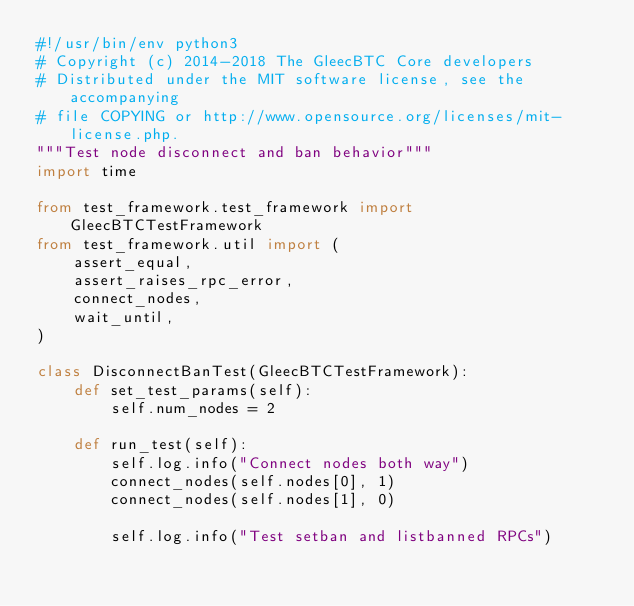Convert code to text. <code><loc_0><loc_0><loc_500><loc_500><_Python_>#!/usr/bin/env python3
# Copyright (c) 2014-2018 The GleecBTC Core developers
# Distributed under the MIT software license, see the accompanying
# file COPYING or http://www.opensource.org/licenses/mit-license.php.
"""Test node disconnect and ban behavior"""
import time

from test_framework.test_framework import GleecBTCTestFramework
from test_framework.util import (
    assert_equal,
    assert_raises_rpc_error,
    connect_nodes,
    wait_until,
)

class DisconnectBanTest(GleecBTCTestFramework):
    def set_test_params(self):
        self.num_nodes = 2

    def run_test(self):
        self.log.info("Connect nodes both way")
        connect_nodes(self.nodes[0], 1)
        connect_nodes(self.nodes[1], 0)

        self.log.info("Test setban and listbanned RPCs")
</code> 